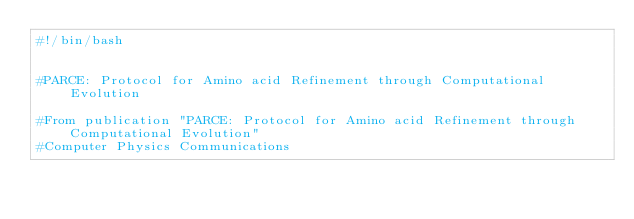<code> <loc_0><loc_0><loc_500><loc_500><_Bash_>#!/bin/bash


#PARCE: Protocol for Amino acid Refinement through Computational Evolution

#From publication "PARCE: Protocol for Amino acid Refinement through Computational Evolution"
#Computer Physics Communications</code> 